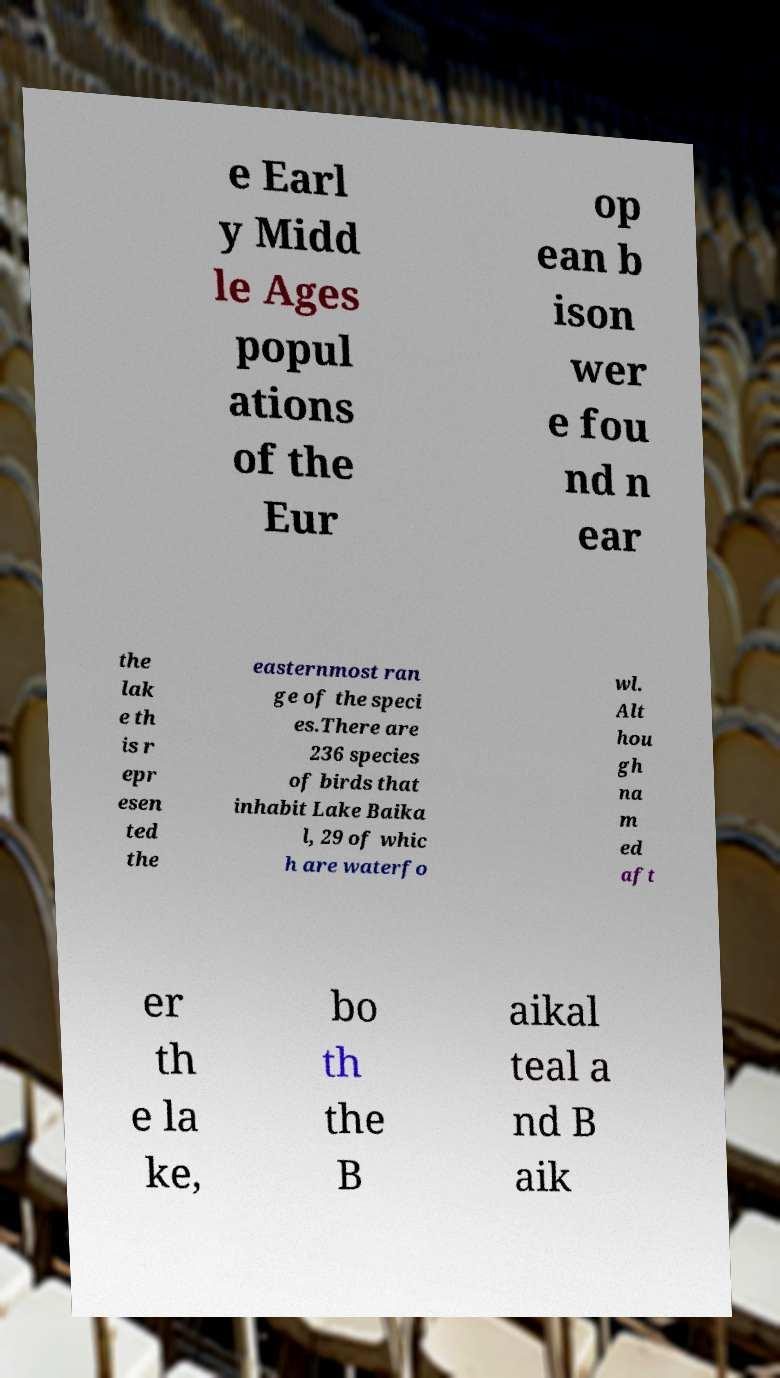There's text embedded in this image that I need extracted. Can you transcribe it verbatim? e Earl y Midd le Ages popul ations of the Eur op ean b ison wer e fou nd n ear the lak e th is r epr esen ted the easternmost ran ge of the speci es.There are 236 species of birds that inhabit Lake Baika l, 29 of whic h are waterfo wl. Alt hou gh na m ed aft er th e la ke, bo th the B aikal teal a nd B aik 